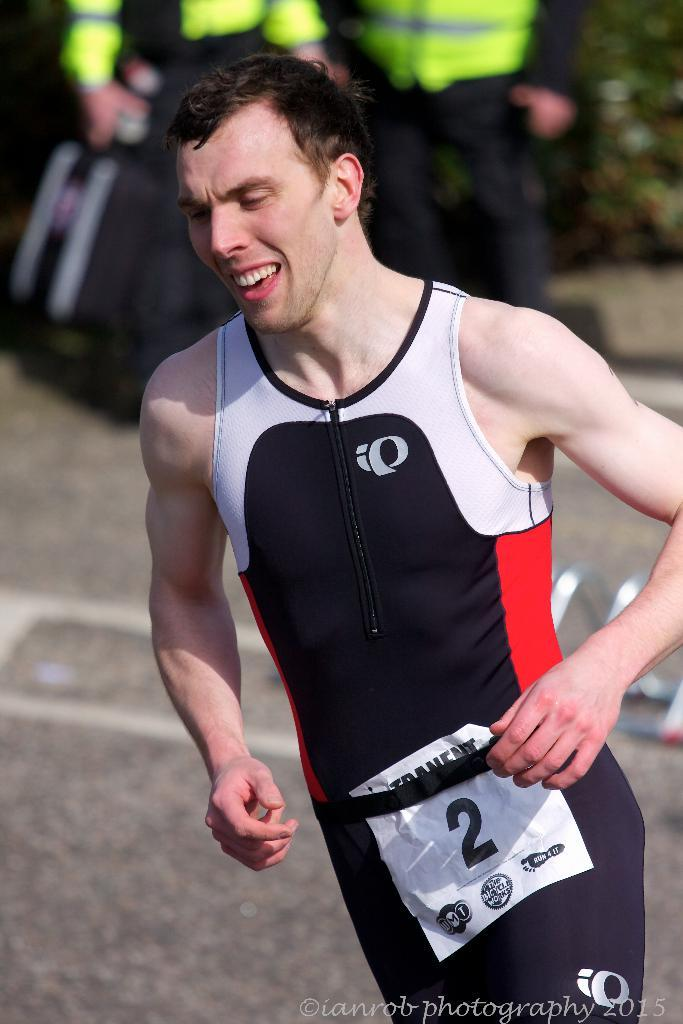<image>
Summarize the visual content of the image. A runner has on a red, white and blue outfit with number 2 on his side. 